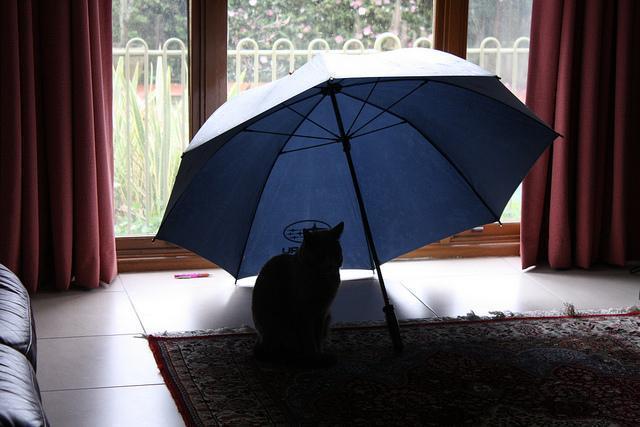Is the caption "The umbrella is at the left side of the couch." a true representation of the image?
Answer yes or no. Yes. 